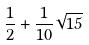Convert formula to latex. <formula><loc_0><loc_0><loc_500><loc_500>\frac { 1 } { 2 } + \frac { 1 } { 1 0 } \sqrt { 1 5 }</formula> 